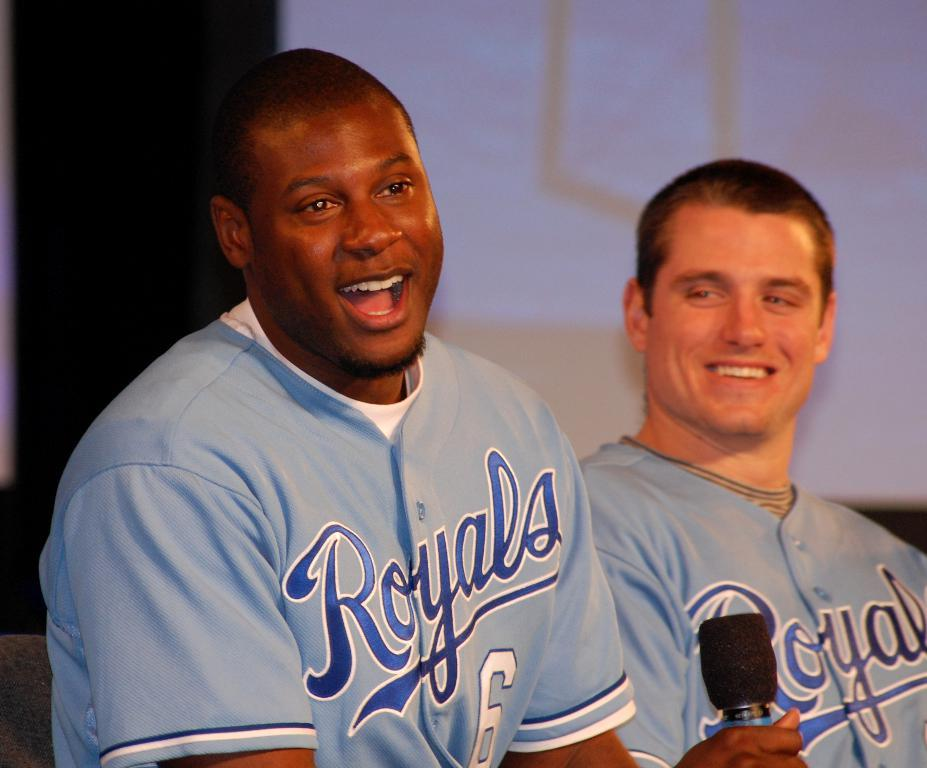How many people are in the image? There are two people in the image. What is one person doing in the image? One person is holding a microphone. What is the facial expression of both people in the image? Both people are smiling. What color are the t-shirts worn by both people in the image? Both people are wearing blue t-shirts. What type of wire can be seen connecting the two people in the image? There is no wire connecting the two people in the image. Can you tell me how many yaks are present in the image? There are no yaks present in the image. 